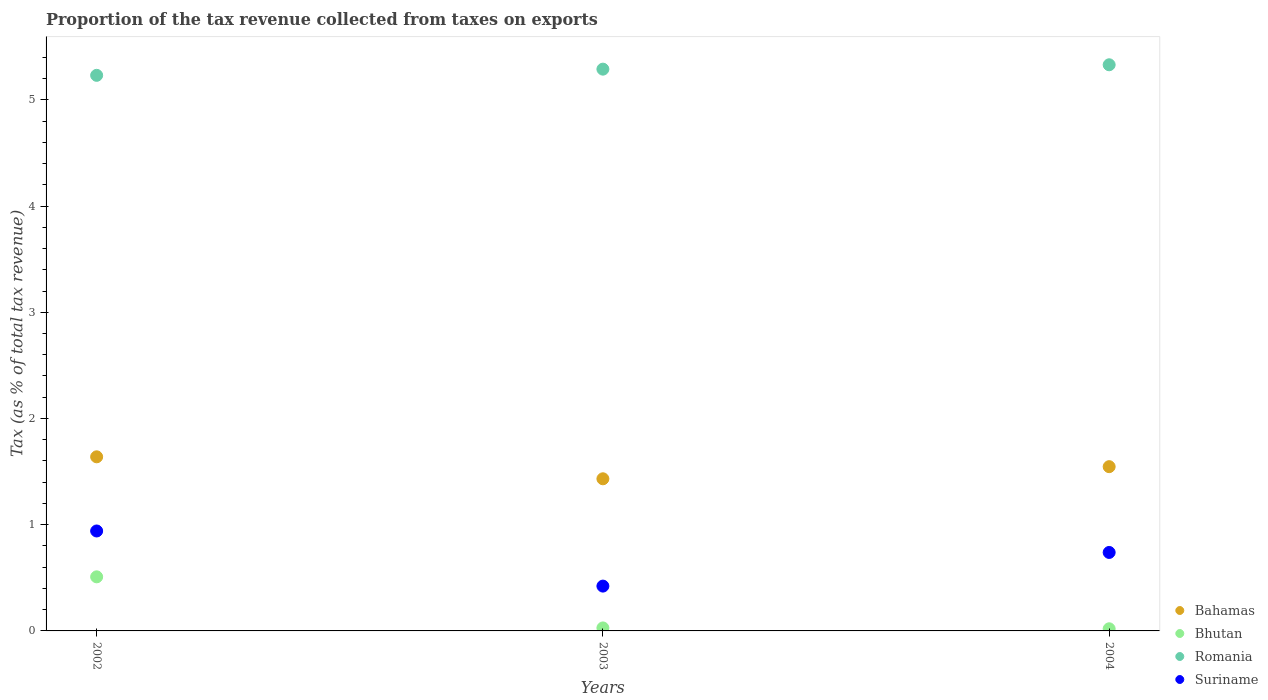Is the number of dotlines equal to the number of legend labels?
Make the answer very short. Yes. What is the proportion of the tax revenue collected in Bahamas in 2002?
Your answer should be very brief. 1.64. Across all years, what is the maximum proportion of the tax revenue collected in Romania?
Ensure brevity in your answer.  5.33. Across all years, what is the minimum proportion of the tax revenue collected in Suriname?
Your answer should be very brief. 0.42. What is the total proportion of the tax revenue collected in Romania in the graph?
Give a very brief answer. 15.85. What is the difference between the proportion of the tax revenue collected in Bahamas in 2003 and that in 2004?
Make the answer very short. -0.11. What is the difference between the proportion of the tax revenue collected in Romania in 2002 and the proportion of the tax revenue collected in Bhutan in 2003?
Ensure brevity in your answer.  5.2. What is the average proportion of the tax revenue collected in Bahamas per year?
Keep it short and to the point. 1.54. In the year 2003, what is the difference between the proportion of the tax revenue collected in Romania and proportion of the tax revenue collected in Bahamas?
Provide a succinct answer. 3.86. In how many years, is the proportion of the tax revenue collected in Suriname greater than 2 %?
Your response must be concise. 0. What is the ratio of the proportion of the tax revenue collected in Bahamas in 2003 to that in 2004?
Make the answer very short. 0.93. Is the proportion of the tax revenue collected in Suriname in 2002 less than that in 2003?
Provide a short and direct response. No. What is the difference between the highest and the second highest proportion of the tax revenue collected in Bhutan?
Your answer should be compact. 0.48. What is the difference between the highest and the lowest proportion of the tax revenue collected in Bhutan?
Offer a very short reply. 0.49. Is it the case that in every year, the sum of the proportion of the tax revenue collected in Bhutan and proportion of the tax revenue collected in Suriname  is greater than the sum of proportion of the tax revenue collected in Romania and proportion of the tax revenue collected in Bahamas?
Ensure brevity in your answer.  No. Is the proportion of the tax revenue collected in Bhutan strictly less than the proportion of the tax revenue collected in Suriname over the years?
Keep it short and to the point. Yes. How many dotlines are there?
Keep it short and to the point. 4. How many years are there in the graph?
Provide a short and direct response. 3. What is the difference between two consecutive major ticks on the Y-axis?
Offer a very short reply. 1. Where does the legend appear in the graph?
Your answer should be very brief. Bottom right. How are the legend labels stacked?
Keep it short and to the point. Vertical. What is the title of the graph?
Provide a succinct answer. Proportion of the tax revenue collected from taxes on exports. What is the label or title of the X-axis?
Your response must be concise. Years. What is the label or title of the Y-axis?
Make the answer very short. Tax (as % of total tax revenue). What is the Tax (as % of total tax revenue) of Bahamas in 2002?
Keep it short and to the point. 1.64. What is the Tax (as % of total tax revenue) of Bhutan in 2002?
Give a very brief answer. 0.51. What is the Tax (as % of total tax revenue) of Romania in 2002?
Ensure brevity in your answer.  5.23. What is the Tax (as % of total tax revenue) of Suriname in 2002?
Your response must be concise. 0.94. What is the Tax (as % of total tax revenue) in Bahamas in 2003?
Keep it short and to the point. 1.43. What is the Tax (as % of total tax revenue) of Bhutan in 2003?
Ensure brevity in your answer.  0.03. What is the Tax (as % of total tax revenue) of Romania in 2003?
Your answer should be compact. 5.29. What is the Tax (as % of total tax revenue) of Suriname in 2003?
Offer a very short reply. 0.42. What is the Tax (as % of total tax revenue) of Bahamas in 2004?
Your answer should be very brief. 1.55. What is the Tax (as % of total tax revenue) in Bhutan in 2004?
Your response must be concise. 0.02. What is the Tax (as % of total tax revenue) of Romania in 2004?
Your answer should be very brief. 5.33. What is the Tax (as % of total tax revenue) in Suriname in 2004?
Give a very brief answer. 0.74. Across all years, what is the maximum Tax (as % of total tax revenue) in Bahamas?
Offer a very short reply. 1.64. Across all years, what is the maximum Tax (as % of total tax revenue) in Bhutan?
Ensure brevity in your answer.  0.51. Across all years, what is the maximum Tax (as % of total tax revenue) in Romania?
Provide a succinct answer. 5.33. Across all years, what is the maximum Tax (as % of total tax revenue) of Suriname?
Your response must be concise. 0.94. Across all years, what is the minimum Tax (as % of total tax revenue) in Bahamas?
Make the answer very short. 1.43. Across all years, what is the minimum Tax (as % of total tax revenue) in Bhutan?
Make the answer very short. 0.02. Across all years, what is the minimum Tax (as % of total tax revenue) of Romania?
Offer a very short reply. 5.23. Across all years, what is the minimum Tax (as % of total tax revenue) of Suriname?
Give a very brief answer. 0.42. What is the total Tax (as % of total tax revenue) in Bahamas in the graph?
Your answer should be very brief. 4.62. What is the total Tax (as % of total tax revenue) of Bhutan in the graph?
Your answer should be compact. 0.56. What is the total Tax (as % of total tax revenue) in Romania in the graph?
Make the answer very short. 15.85. What is the total Tax (as % of total tax revenue) in Suriname in the graph?
Give a very brief answer. 2.1. What is the difference between the Tax (as % of total tax revenue) in Bahamas in 2002 and that in 2003?
Your response must be concise. 0.21. What is the difference between the Tax (as % of total tax revenue) of Bhutan in 2002 and that in 2003?
Offer a terse response. 0.48. What is the difference between the Tax (as % of total tax revenue) in Romania in 2002 and that in 2003?
Your answer should be very brief. -0.06. What is the difference between the Tax (as % of total tax revenue) of Suriname in 2002 and that in 2003?
Provide a short and direct response. 0.52. What is the difference between the Tax (as % of total tax revenue) of Bahamas in 2002 and that in 2004?
Offer a terse response. 0.09. What is the difference between the Tax (as % of total tax revenue) of Bhutan in 2002 and that in 2004?
Your answer should be compact. 0.49. What is the difference between the Tax (as % of total tax revenue) in Romania in 2002 and that in 2004?
Provide a short and direct response. -0.1. What is the difference between the Tax (as % of total tax revenue) in Suriname in 2002 and that in 2004?
Provide a short and direct response. 0.2. What is the difference between the Tax (as % of total tax revenue) of Bahamas in 2003 and that in 2004?
Give a very brief answer. -0.11. What is the difference between the Tax (as % of total tax revenue) of Bhutan in 2003 and that in 2004?
Keep it short and to the point. 0.01. What is the difference between the Tax (as % of total tax revenue) in Romania in 2003 and that in 2004?
Provide a succinct answer. -0.04. What is the difference between the Tax (as % of total tax revenue) of Suriname in 2003 and that in 2004?
Your answer should be very brief. -0.32. What is the difference between the Tax (as % of total tax revenue) of Bahamas in 2002 and the Tax (as % of total tax revenue) of Bhutan in 2003?
Give a very brief answer. 1.61. What is the difference between the Tax (as % of total tax revenue) in Bahamas in 2002 and the Tax (as % of total tax revenue) in Romania in 2003?
Offer a very short reply. -3.65. What is the difference between the Tax (as % of total tax revenue) in Bahamas in 2002 and the Tax (as % of total tax revenue) in Suriname in 2003?
Offer a terse response. 1.22. What is the difference between the Tax (as % of total tax revenue) in Bhutan in 2002 and the Tax (as % of total tax revenue) in Romania in 2003?
Provide a short and direct response. -4.78. What is the difference between the Tax (as % of total tax revenue) of Bhutan in 2002 and the Tax (as % of total tax revenue) of Suriname in 2003?
Provide a short and direct response. 0.09. What is the difference between the Tax (as % of total tax revenue) in Romania in 2002 and the Tax (as % of total tax revenue) in Suriname in 2003?
Your answer should be very brief. 4.81. What is the difference between the Tax (as % of total tax revenue) of Bahamas in 2002 and the Tax (as % of total tax revenue) of Bhutan in 2004?
Offer a very short reply. 1.62. What is the difference between the Tax (as % of total tax revenue) in Bahamas in 2002 and the Tax (as % of total tax revenue) in Romania in 2004?
Provide a succinct answer. -3.69. What is the difference between the Tax (as % of total tax revenue) of Bahamas in 2002 and the Tax (as % of total tax revenue) of Suriname in 2004?
Provide a succinct answer. 0.9. What is the difference between the Tax (as % of total tax revenue) in Bhutan in 2002 and the Tax (as % of total tax revenue) in Romania in 2004?
Your answer should be very brief. -4.82. What is the difference between the Tax (as % of total tax revenue) of Bhutan in 2002 and the Tax (as % of total tax revenue) of Suriname in 2004?
Your answer should be very brief. -0.23. What is the difference between the Tax (as % of total tax revenue) in Romania in 2002 and the Tax (as % of total tax revenue) in Suriname in 2004?
Ensure brevity in your answer.  4.49. What is the difference between the Tax (as % of total tax revenue) of Bahamas in 2003 and the Tax (as % of total tax revenue) of Bhutan in 2004?
Provide a short and direct response. 1.41. What is the difference between the Tax (as % of total tax revenue) in Bahamas in 2003 and the Tax (as % of total tax revenue) in Romania in 2004?
Make the answer very short. -3.9. What is the difference between the Tax (as % of total tax revenue) in Bahamas in 2003 and the Tax (as % of total tax revenue) in Suriname in 2004?
Provide a succinct answer. 0.69. What is the difference between the Tax (as % of total tax revenue) of Bhutan in 2003 and the Tax (as % of total tax revenue) of Romania in 2004?
Your answer should be very brief. -5.3. What is the difference between the Tax (as % of total tax revenue) in Bhutan in 2003 and the Tax (as % of total tax revenue) in Suriname in 2004?
Provide a short and direct response. -0.71. What is the difference between the Tax (as % of total tax revenue) of Romania in 2003 and the Tax (as % of total tax revenue) of Suriname in 2004?
Your answer should be compact. 4.55. What is the average Tax (as % of total tax revenue) in Bahamas per year?
Your response must be concise. 1.54. What is the average Tax (as % of total tax revenue) of Bhutan per year?
Give a very brief answer. 0.19. What is the average Tax (as % of total tax revenue) in Romania per year?
Provide a succinct answer. 5.28. What is the average Tax (as % of total tax revenue) of Suriname per year?
Make the answer very short. 0.7. In the year 2002, what is the difference between the Tax (as % of total tax revenue) in Bahamas and Tax (as % of total tax revenue) in Bhutan?
Ensure brevity in your answer.  1.13. In the year 2002, what is the difference between the Tax (as % of total tax revenue) in Bahamas and Tax (as % of total tax revenue) in Romania?
Make the answer very short. -3.59. In the year 2002, what is the difference between the Tax (as % of total tax revenue) of Bahamas and Tax (as % of total tax revenue) of Suriname?
Provide a succinct answer. 0.7. In the year 2002, what is the difference between the Tax (as % of total tax revenue) in Bhutan and Tax (as % of total tax revenue) in Romania?
Your response must be concise. -4.72. In the year 2002, what is the difference between the Tax (as % of total tax revenue) of Bhutan and Tax (as % of total tax revenue) of Suriname?
Give a very brief answer. -0.43. In the year 2002, what is the difference between the Tax (as % of total tax revenue) in Romania and Tax (as % of total tax revenue) in Suriname?
Provide a short and direct response. 4.29. In the year 2003, what is the difference between the Tax (as % of total tax revenue) in Bahamas and Tax (as % of total tax revenue) in Bhutan?
Your response must be concise. 1.4. In the year 2003, what is the difference between the Tax (as % of total tax revenue) of Bahamas and Tax (as % of total tax revenue) of Romania?
Offer a very short reply. -3.86. In the year 2003, what is the difference between the Tax (as % of total tax revenue) of Bahamas and Tax (as % of total tax revenue) of Suriname?
Offer a very short reply. 1.01. In the year 2003, what is the difference between the Tax (as % of total tax revenue) in Bhutan and Tax (as % of total tax revenue) in Romania?
Give a very brief answer. -5.26. In the year 2003, what is the difference between the Tax (as % of total tax revenue) of Bhutan and Tax (as % of total tax revenue) of Suriname?
Offer a terse response. -0.39. In the year 2003, what is the difference between the Tax (as % of total tax revenue) in Romania and Tax (as % of total tax revenue) in Suriname?
Give a very brief answer. 4.87. In the year 2004, what is the difference between the Tax (as % of total tax revenue) in Bahamas and Tax (as % of total tax revenue) in Bhutan?
Keep it short and to the point. 1.53. In the year 2004, what is the difference between the Tax (as % of total tax revenue) of Bahamas and Tax (as % of total tax revenue) of Romania?
Your answer should be very brief. -3.78. In the year 2004, what is the difference between the Tax (as % of total tax revenue) of Bahamas and Tax (as % of total tax revenue) of Suriname?
Offer a very short reply. 0.81. In the year 2004, what is the difference between the Tax (as % of total tax revenue) in Bhutan and Tax (as % of total tax revenue) in Romania?
Offer a very short reply. -5.31. In the year 2004, what is the difference between the Tax (as % of total tax revenue) in Bhutan and Tax (as % of total tax revenue) in Suriname?
Offer a very short reply. -0.72. In the year 2004, what is the difference between the Tax (as % of total tax revenue) of Romania and Tax (as % of total tax revenue) of Suriname?
Your answer should be compact. 4.59. What is the ratio of the Tax (as % of total tax revenue) in Bahamas in 2002 to that in 2003?
Ensure brevity in your answer.  1.14. What is the ratio of the Tax (as % of total tax revenue) in Bhutan in 2002 to that in 2003?
Keep it short and to the point. 18.11. What is the ratio of the Tax (as % of total tax revenue) of Suriname in 2002 to that in 2003?
Offer a terse response. 2.23. What is the ratio of the Tax (as % of total tax revenue) in Bahamas in 2002 to that in 2004?
Keep it short and to the point. 1.06. What is the ratio of the Tax (as % of total tax revenue) of Bhutan in 2002 to that in 2004?
Provide a short and direct response. 25.37. What is the ratio of the Tax (as % of total tax revenue) of Romania in 2002 to that in 2004?
Make the answer very short. 0.98. What is the ratio of the Tax (as % of total tax revenue) of Suriname in 2002 to that in 2004?
Give a very brief answer. 1.27. What is the ratio of the Tax (as % of total tax revenue) in Bahamas in 2003 to that in 2004?
Keep it short and to the point. 0.93. What is the ratio of the Tax (as % of total tax revenue) in Bhutan in 2003 to that in 2004?
Your response must be concise. 1.4. What is the ratio of the Tax (as % of total tax revenue) in Romania in 2003 to that in 2004?
Your answer should be compact. 0.99. What is the ratio of the Tax (as % of total tax revenue) of Suriname in 2003 to that in 2004?
Provide a short and direct response. 0.57. What is the difference between the highest and the second highest Tax (as % of total tax revenue) in Bahamas?
Your answer should be very brief. 0.09. What is the difference between the highest and the second highest Tax (as % of total tax revenue) in Bhutan?
Give a very brief answer. 0.48. What is the difference between the highest and the second highest Tax (as % of total tax revenue) in Romania?
Offer a very short reply. 0.04. What is the difference between the highest and the second highest Tax (as % of total tax revenue) of Suriname?
Your answer should be very brief. 0.2. What is the difference between the highest and the lowest Tax (as % of total tax revenue) of Bahamas?
Your answer should be compact. 0.21. What is the difference between the highest and the lowest Tax (as % of total tax revenue) in Bhutan?
Provide a succinct answer. 0.49. What is the difference between the highest and the lowest Tax (as % of total tax revenue) in Romania?
Provide a succinct answer. 0.1. What is the difference between the highest and the lowest Tax (as % of total tax revenue) of Suriname?
Ensure brevity in your answer.  0.52. 